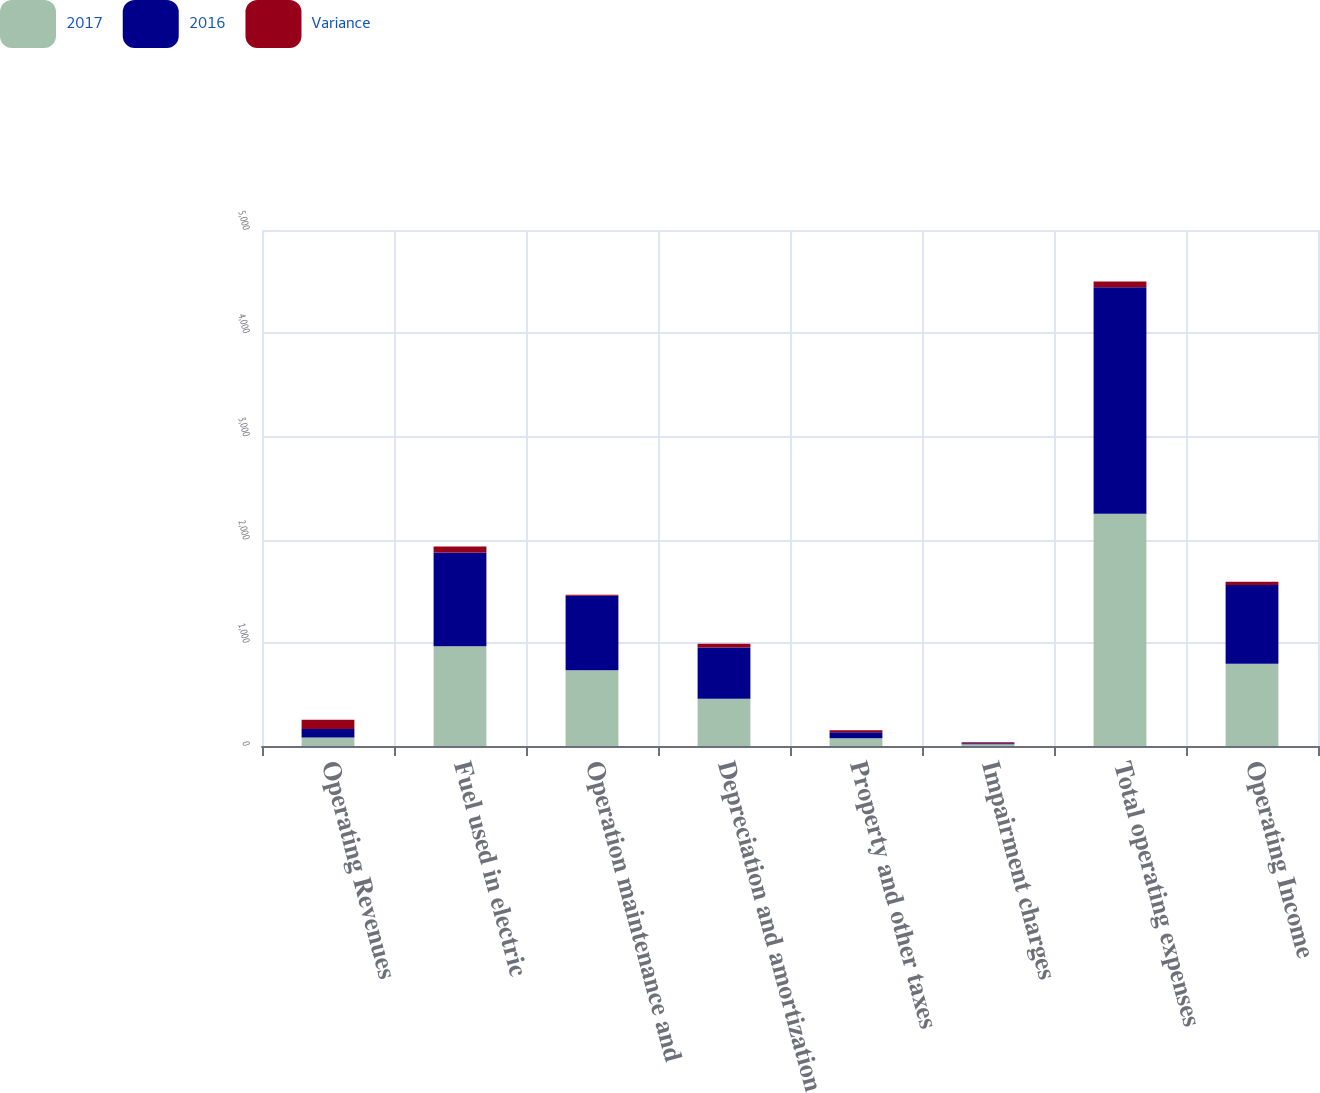Convert chart. <chart><loc_0><loc_0><loc_500><loc_500><stacked_bar_chart><ecel><fcel>Operating Revenues<fcel>Fuel used in electric<fcel>Operation maintenance and<fcel>Depreciation and amortization<fcel>Property and other taxes<fcel>Impairment charges<fcel>Total operating expenses<fcel>Operating Income<nl><fcel>2017<fcel>82.5<fcel>966<fcel>733<fcel>458<fcel>76<fcel>18<fcel>2251<fcel>796<nl><fcel>2016<fcel>82.5<fcel>909<fcel>723<fcel>496<fcel>58<fcel>8<fcel>2194<fcel>765<nl><fcel>Variance<fcel>89<fcel>57<fcel>10<fcel>38<fcel>18<fcel>10<fcel>57<fcel>31<nl></chart> 